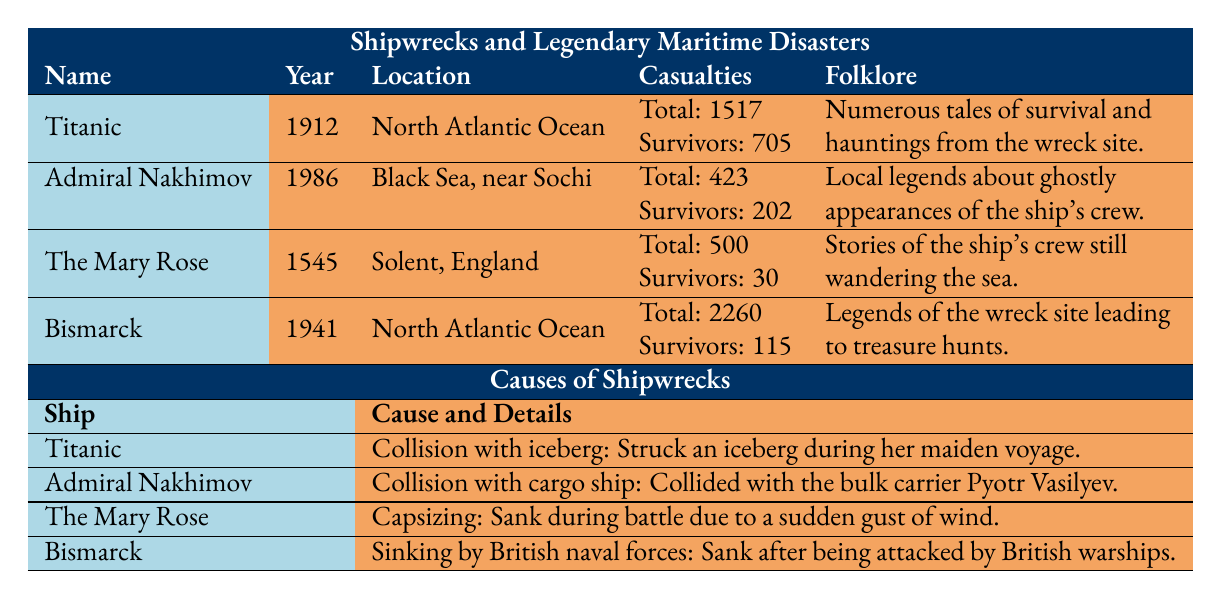What year did the Titanic sink? The table indicates that the Titanic sank in the year 1912, as listed in the "Year" column next to the ship's name.
Answer: 1912 How many total casualties were there in the Admiral Nakhimov disaster? The table states under "Casualties" for Admiral Nakhimov that the total casualties were 423, which is specifically mentioned in that row.
Answer: 423 Which shipwreck had the highest number of total casualties? By comparing the total casualties across all ships listed in the table, Bismarck has 2260 total casualties, which is greater than the others (Titanic: 1517, Admiral Nakhimov: 423, The Mary Rose: 500).
Answer: Bismarck What was the cause of The Mary Rose sinking? According to the table, The Mary Rose sank due to capsizing during battle because of a sudden gust of wind, which is detailed in the "Cause and Details" column.
Answer: Capsizing due to a sudden gust of wind How many survivors were there from the Bismarck? The table shows that the number of survivors from the Bismarck disaster is 115, which is clearly stated in the "Casualties" section of that row.
Answer: 115 Did the Titanic and the Bismarck sink in the same ocean? The Titanic sank in the North Atlantic Ocean, as stated in its respective row, while Bismarck also sank in the North Atlantic Ocean, making this statement true.
Answer: Yes What is the difference in the number of survivors between the Titanic and Admiral Nakhimov? The Titanic had 705 survivors and Admiral Nakhimov had 202 survivors. Calculating the difference: 705 - 202 = 503.
Answer: 503 Which shipwreck had legends associated with ghostly crew appearances? The table indicates that the Admiral Nakhimov has folklore that includes local legends about ghostly appearances of the ship's crew specifically listed in the "Folklore" column for that ship.
Answer: Admiral Nakhimov What was the specific cause of the Bismarck sinking? The Bismarck sank due to being attacked by British naval forces, which is stated in the "Cause and Details" section of the Bismarck row in the table.
Answer: Sinking by British naval forces 